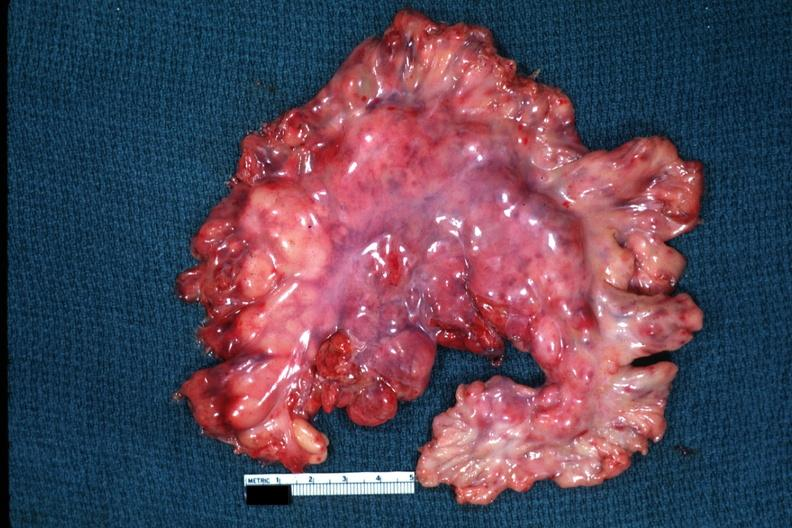what is present?
Answer the question using a single word or phrase. Mesentery 